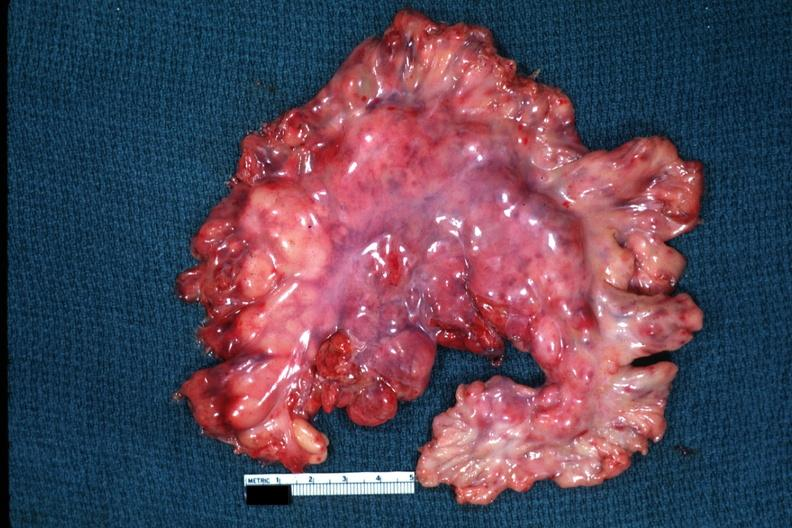what is present?
Answer the question using a single word or phrase. Mesentery 